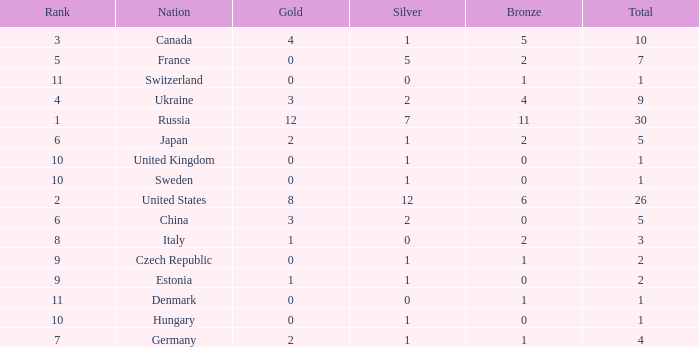How many silvers have a Nation of hungary, and a Rank larger than 10? 0.0. 